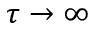Convert formula to latex. <formula><loc_0><loc_0><loc_500><loc_500>\tau \rightarrow \infty</formula> 